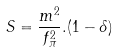Convert formula to latex. <formula><loc_0><loc_0><loc_500><loc_500>S = \frac { m ^ { 2 } } { f _ { \pi } ^ { 2 } } . ( 1 - \delta )</formula> 